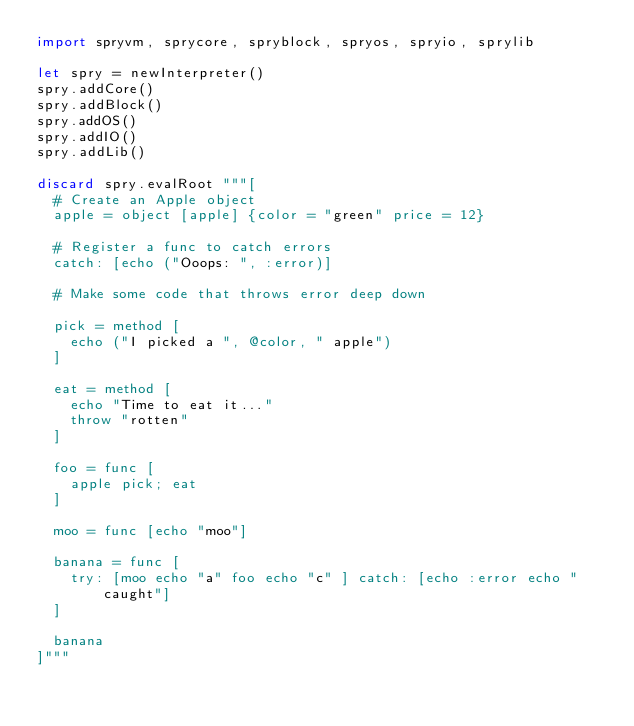<code> <loc_0><loc_0><loc_500><loc_500><_Nim_>import spryvm, sprycore, spryblock, spryos, spryio, sprylib

let spry = newInterpreter()
spry.addCore()
spry.addBlock()
spry.addOS()
spry.addIO()
spry.addLib()

discard spry.evalRoot """[
  # Create an Apple object
  apple = object [apple] {color = "green" price = 12}

  # Register a func to catch errors
  catch: [echo ("Ooops: ", :error)]

  # Make some code that throws error deep down

  pick = method [
    echo ("I picked a ", @color, " apple")
  ]

  eat = method [
    echo "Time to eat it..."
    throw "rotten"
  ]

  foo = func [
    apple pick; eat
  ]

  moo = func [echo "moo"]

  banana = func [
    try: [moo echo "a" foo echo "c" ] catch: [echo :error echo "caught"]
  ]

  banana
]"""
</code> 